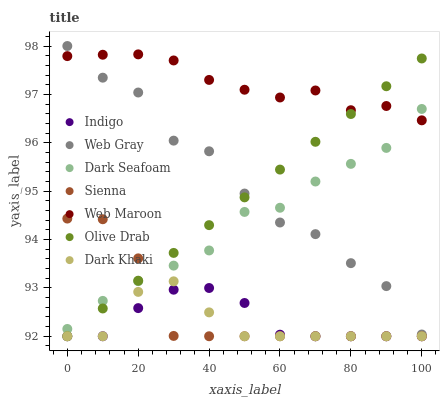Does Dark Khaki have the minimum area under the curve?
Answer yes or no. Yes. Does Web Maroon have the maximum area under the curve?
Answer yes or no. Yes. Does Web Gray have the minimum area under the curve?
Answer yes or no. No. Does Web Gray have the maximum area under the curve?
Answer yes or no. No. Is Olive Drab the smoothest?
Answer yes or no. Yes. Is Web Gray the roughest?
Answer yes or no. Yes. Is Indigo the smoothest?
Answer yes or no. No. Is Indigo the roughest?
Answer yes or no. No. Does Dark Khaki have the lowest value?
Answer yes or no. Yes. Does Web Gray have the lowest value?
Answer yes or no. No. Does Web Gray have the highest value?
Answer yes or no. Yes. Does Indigo have the highest value?
Answer yes or no. No. Is Dark Khaki less than Web Gray?
Answer yes or no. Yes. Is Web Gray greater than Dark Khaki?
Answer yes or no. Yes. Does Dark Khaki intersect Sienna?
Answer yes or no. Yes. Is Dark Khaki less than Sienna?
Answer yes or no. No. Is Dark Khaki greater than Sienna?
Answer yes or no. No. Does Dark Khaki intersect Web Gray?
Answer yes or no. No. 